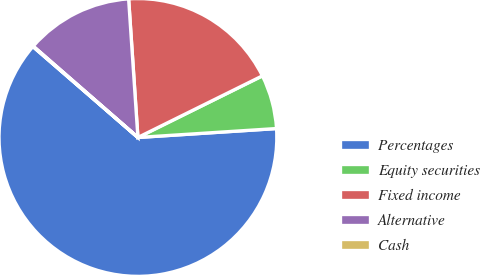Convert chart to OTSL. <chart><loc_0><loc_0><loc_500><loc_500><pie_chart><fcel>Percentages<fcel>Equity securities<fcel>Fixed income<fcel>Alternative<fcel>Cash<nl><fcel>62.37%<fcel>6.29%<fcel>18.75%<fcel>12.52%<fcel>0.06%<nl></chart> 